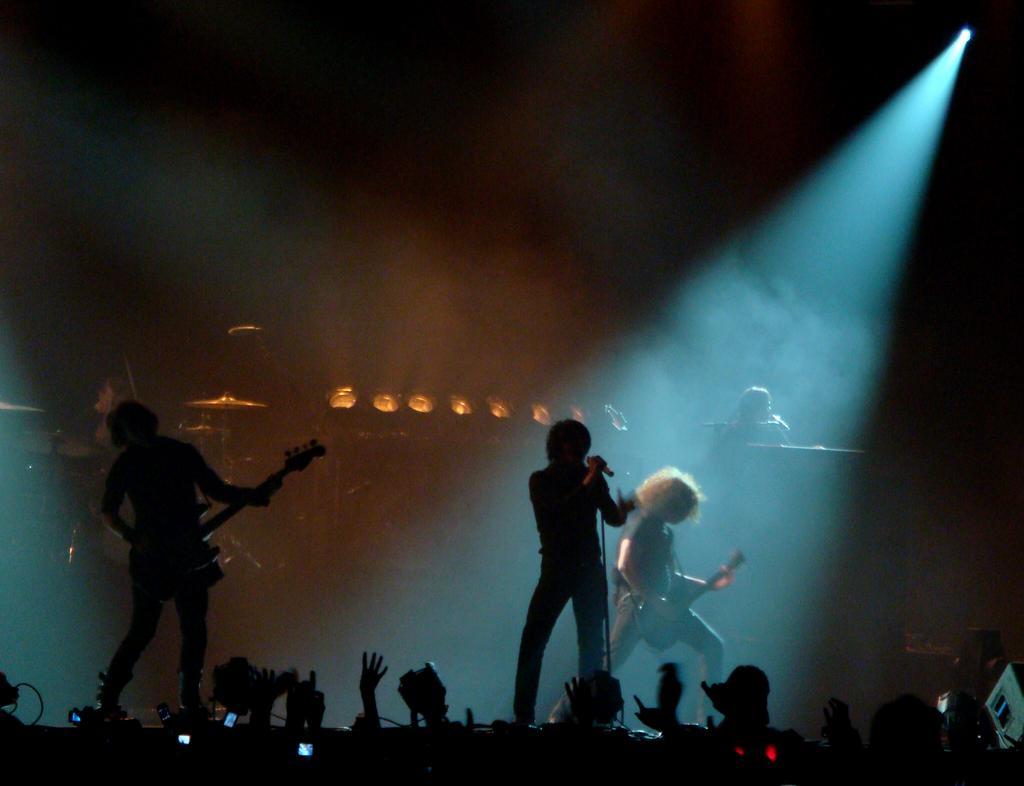In one or two sentences, can you explain what this image depicts? In this image we can see there are people standing on the stage and a few people standing on the floor. And there are two people playing musical instruments. And there is a person singing and holding a microphone. At the back there are lights. 